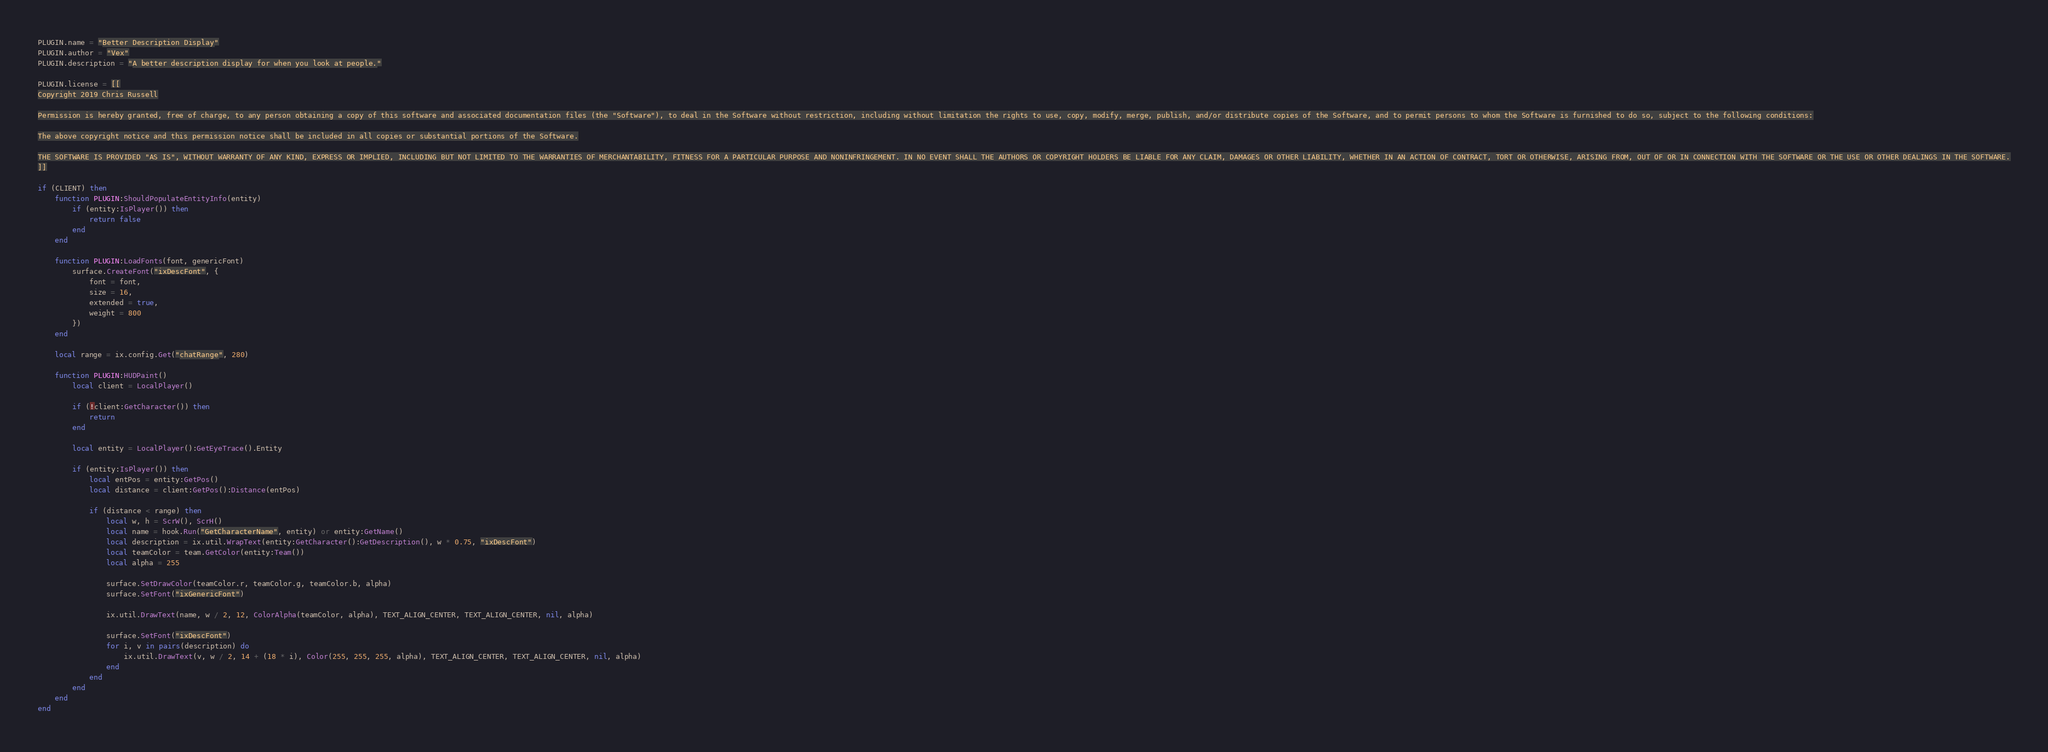Convert code to text. <code><loc_0><loc_0><loc_500><loc_500><_Lua_>PLUGIN.name = "Better Description Display"
PLUGIN.author = "Vex"
PLUGIN.description = "A better description display for when you look at people."

PLUGIN.license = [[
Copyright 2019 Chris Russell

Permission is hereby granted, free of charge, to any person obtaining a copy of this software and associated documentation files (the "Software"), to deal in the Software without restriction, including without limitation the rights to use, copy, modify, merge, publish, and/or distribute copies of the Software, and to permit persons to whom the Software is furnished to do so, subject to the following conditions:

The above copyright notice and this permission notice shall be included in all copies or substantial portions of the Software.

THE SOFTWARE IS PROVIDED "AS IS", WITHOUT WARRANTY OF ANY KIND, EXPRESS OR IMPLIED, INCLUDING BUT NOT LIMITED TO THE WARRANTIES OF MERCHANTABILITY, FITNESS FOR A PARTICULAR PURPOSE AND NONINFRINGEMENT. IN NO EVENT SHALL THE AUTHORS OR COPYRIGHT HOLDERS BE LIABLE FOR ANY CLAIM, DAMAGES OR OTHER LIABILITY, WHETHER IN AN ACTION OF CONTRACT, TORT OR OTHERWISE, ARISING FROM, OUT OF OR IN CONNECTION WITH THE SOFTWARE OR THE USE OR OTHER DEALINGS IN THE SOFTWARE.
]]

if (CLIENT) then
	function PLUGIN:ShouldPopulateEntityInfo(entity)
		if (entity:IsPlayer()) then
			return false
		end
	end

	function PLUGIN:LoadFonts(font, genericFont)
		surface.CreateFont("ixDescFont", {
			font = font,
			size = 16,
			extended = true,
			weight = 800
		})
	end

	local range = ix.config.Get("chatRange", 280)

	function PLUGIN:HUDPaint()
		local client = LocalPlayer()

		if (!client:GetCharacter()) then
			return
		end

		local entity = LocalPlayer():GetEyeTrace().Entity

		if (entity:IsPlayer()) then
			local entPos = entity:GetPos()
			local distance = client:GetPos():Distance(entPos)

			if (distance < range) then
				local w, h = ScrW(), ScrH()
				local name = hook.Run("GetCharacterName", entity) or entity:GetName()
				local description = ix.util.WrapText(entity:GetCharacter():GetDescription(), w * 0.75, "ixDescFont")
				local teamColor = team.GetColor(entity:Team())
				local alpha = 255

				surface.SetDrawColor(teamColor.r, teamColor.g, teamColor.b, alpha)
				surface.SetFont("ixGenericFont")

				ix.util.DrawText(name, w / 2, 12, ColorAlpha(teamColor, alpha), TEXT_ALIGN_CENTER, TEXT_ALIGN_CENTER, nil, alpha)

				surface.SetFont("ixDescFont")
				for i, v in pairs(description) do
					ix.util.DrawText(v, w / 2, 14 + (18 * i), Color(255, 255, 255, alpha), TEXT_ALIGN_CENTER, TEXT_ALIGN_CENTER, nil, alpha)
				end
			end
		end
	end
end
</code> 